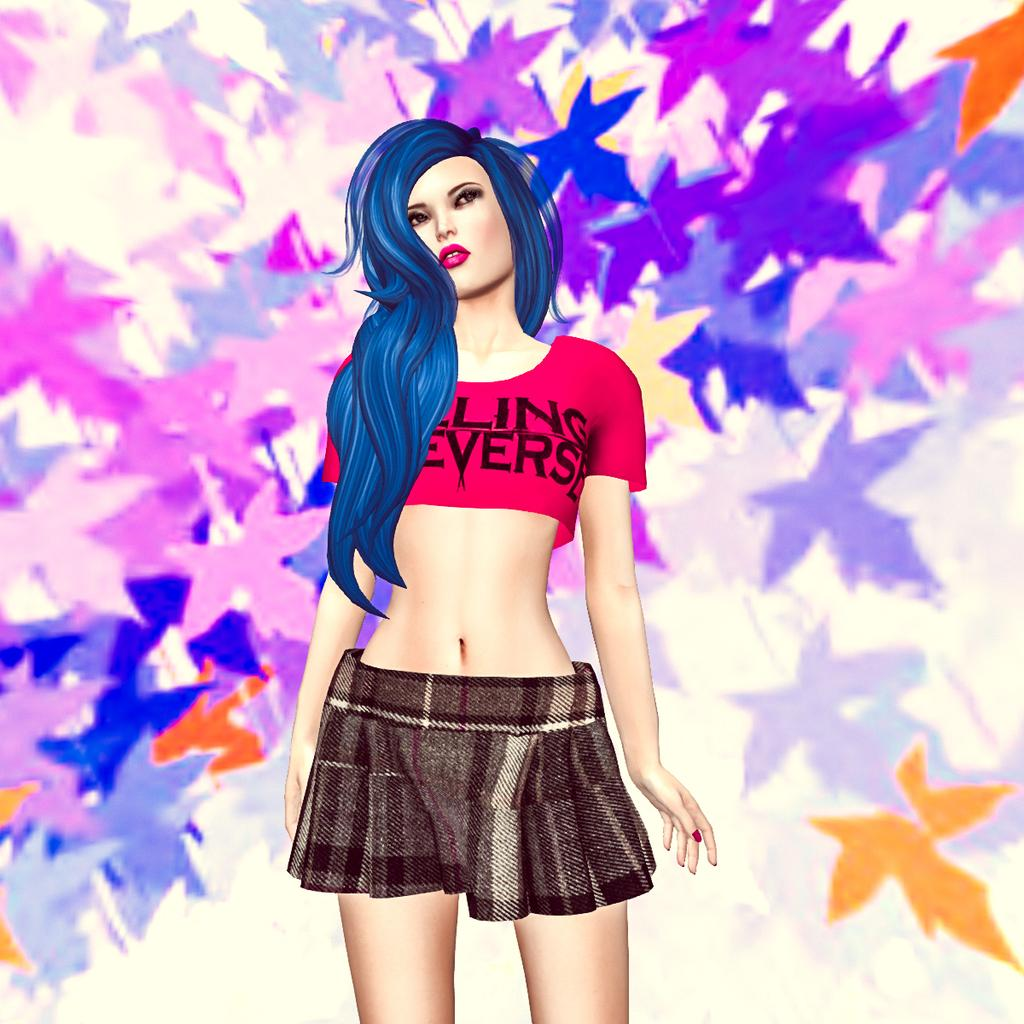<image>
Offer a succinct explanation of the picture presented. The word Ling is written in black on the pink top. 